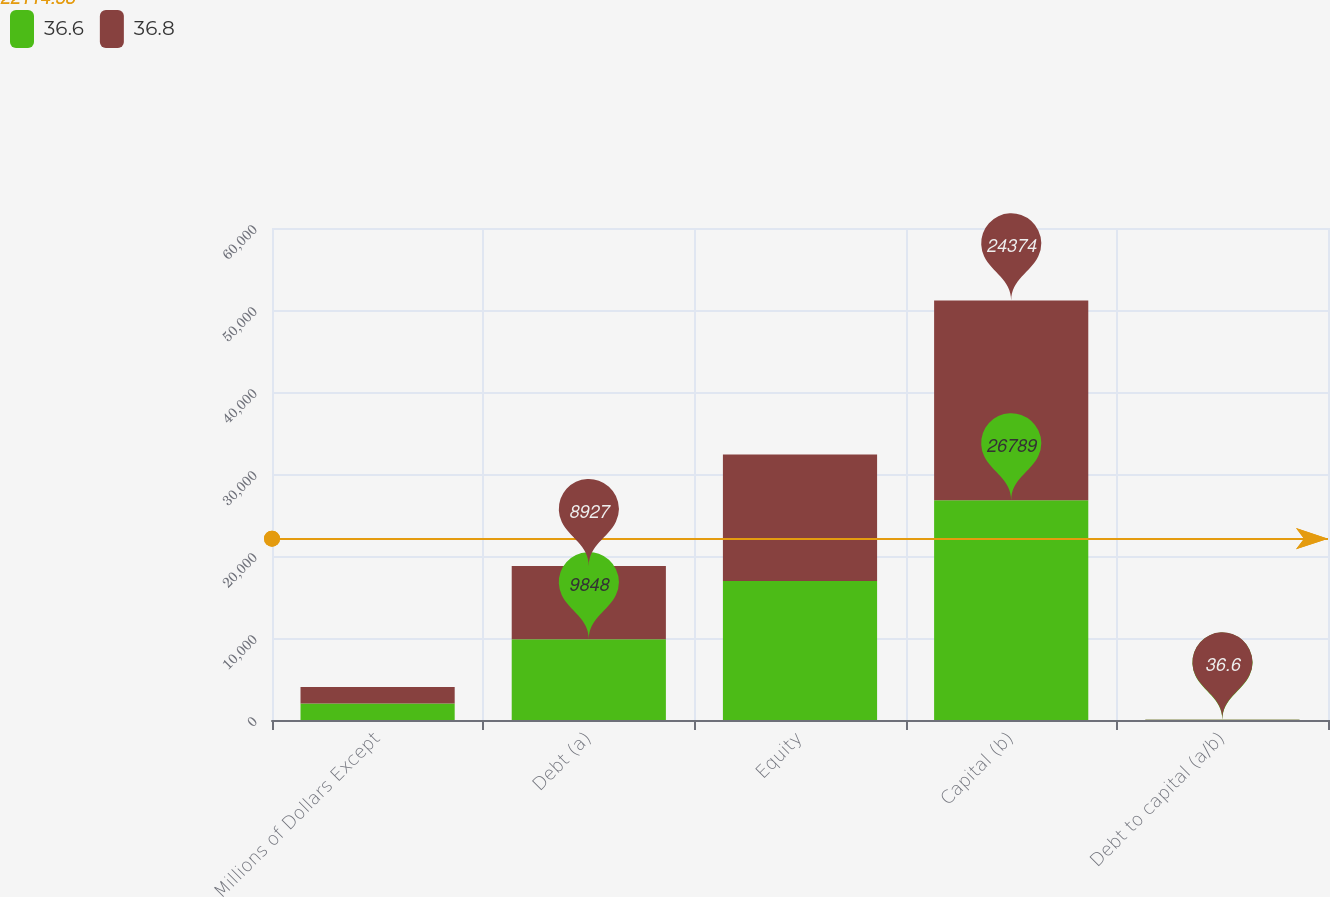Convert chart. <chart><loc_0><loc_0><loc_500><loc_500><stacked_bar_chart><ecel><fcel>Millions of Dollars Except<fcel>Debt (a)<fcel>Equity<fcel>Capital (b)<fcel>Debt to capital (a/b)<nl><fcel>36.6<fcel>2009<fcel>9848<fcel>16941<fcel>26789<fcel>36.8<nl><fcel>36.8<fcel>2008<fcel>8927<fcel>15447<fcel>24374<fcel>36.6<nl></chart> 